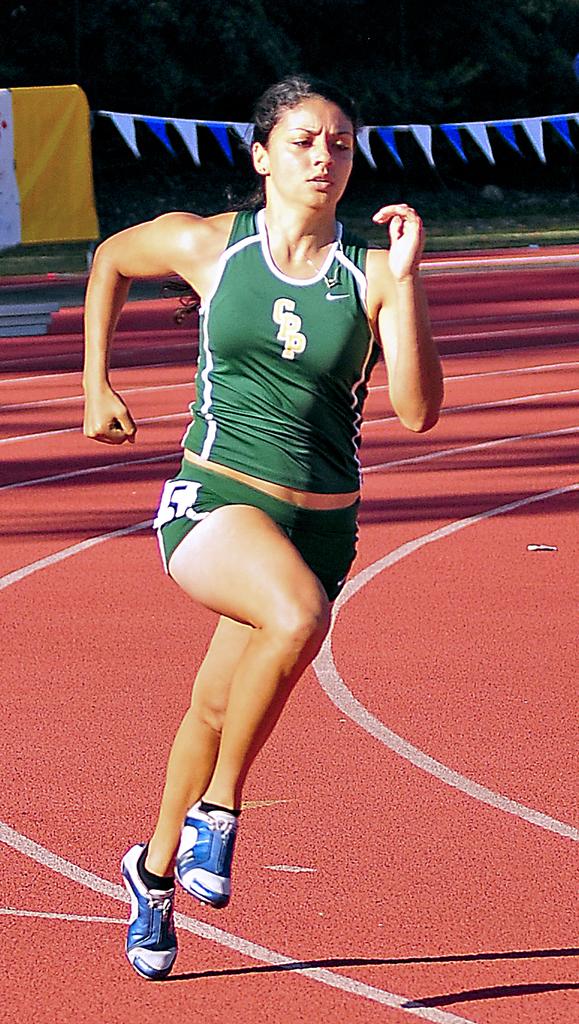What are the initials on the runners shirt?
Offer a terse response. Cpp. 